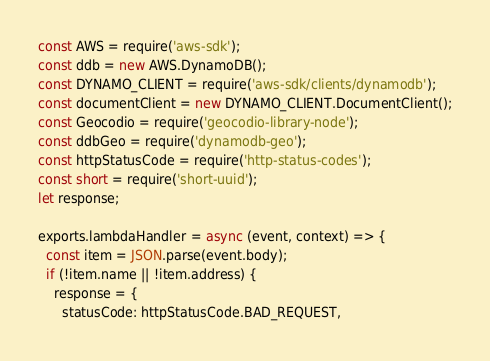Convert code to text. <code><loc_0><loc_0><loc_500><loc_500><_JavaScript_>const AWS = require('aws-sdk');
const ddb = new AWS.DynamoDB();
const DYNAMO_CLIENT = require('aws-sdk/clients/dynamodb');
const documentClient = new DYNAMO_CLIENT.DocumentClient();
const Geocodio = require('geocodio-library-node');
const ddbGeo = require('dynamodb-geo');
const httpStatusCode = require('http-status-codes');
const short = require('short-uuid');
let response;

exports.lambdaHandler = async (event, context) => {
  const item = JSON.parse(event.body);
  if (!item.name || !item.address) {
    response = {
      statusCode: httpStatusCode.BAD_REQUEST,</code> 